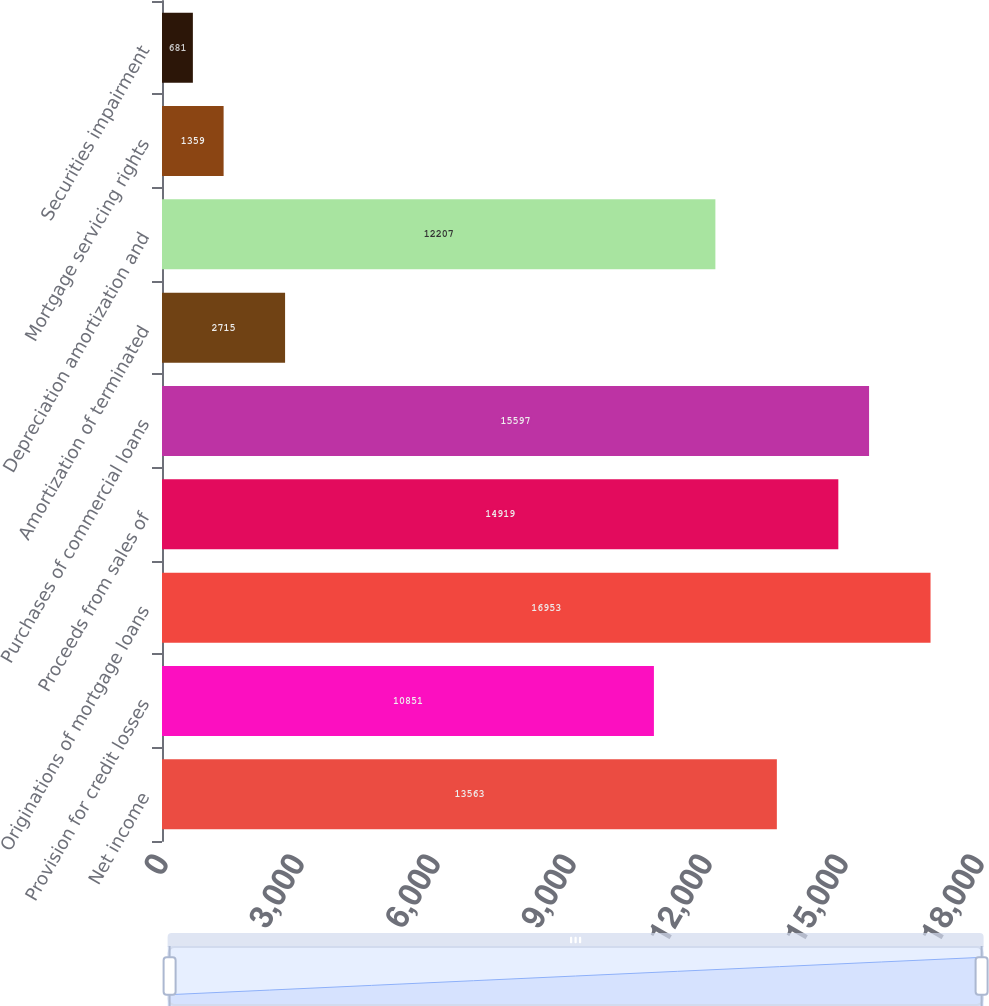<chart> <loc_0><loc_0><loc_500><loc_500><bar_chart><fcel>Net income<fcel>Provision for credit losses<fcel>Originations of mortgage loans<fcel>Proceeds from sales of<fcel>Purchases of commercial loans<fcel>Amortization of terminated<fcel>Depreciation amortization and<fcel>Mortgage servicing rights<fcel>Securities impairment<nl><fcel>13563<fcel>10851<fcel>16953<fcel>14919<fcel>15597<fcel>2715<fcel>12207<fcel>1359<fcel>681<nl></chart> 